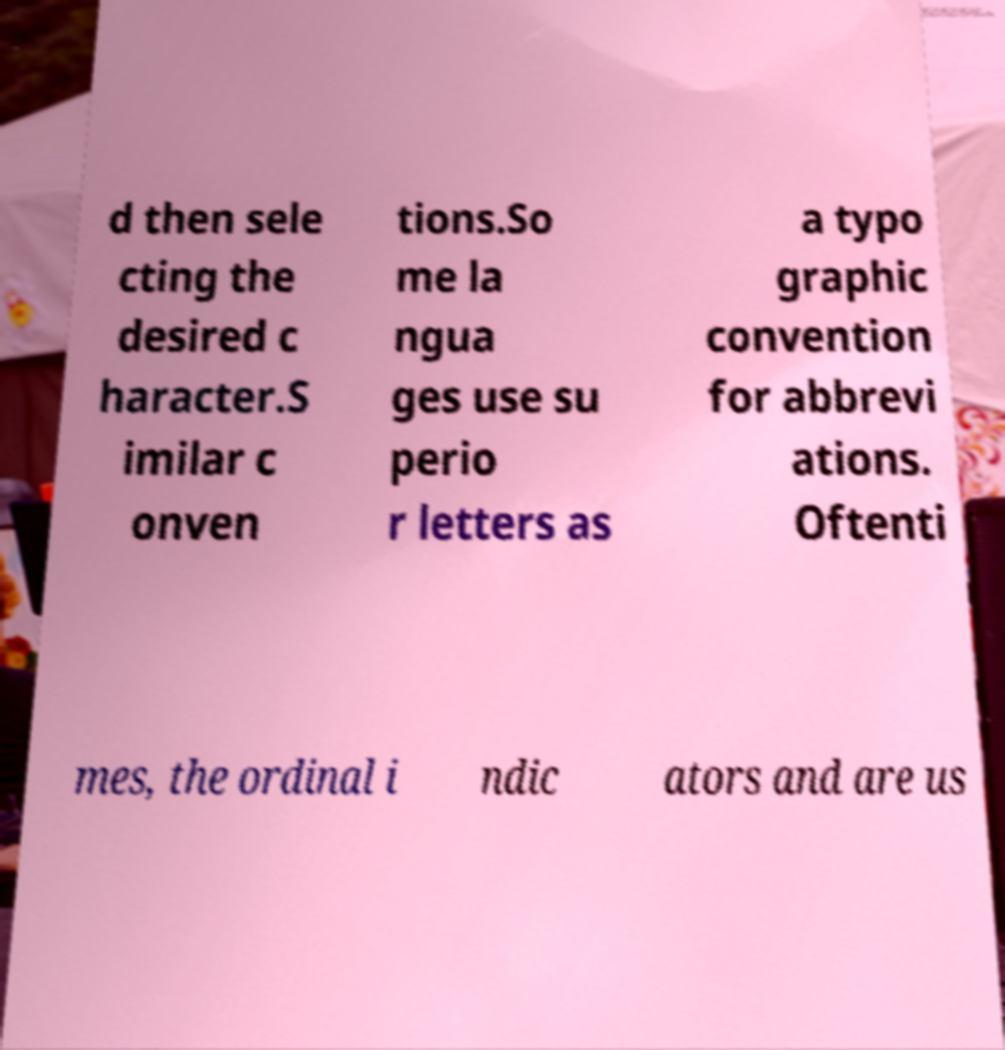Please identify and transcribe the text found in this image. d then sele cting the desired c haracter.S imilar c onven tions.So me la ngua ges use su perio r letters as a typo graphic convention for abbrevi ations. Oftenti mes, the ordinal i ndic ators and are us 